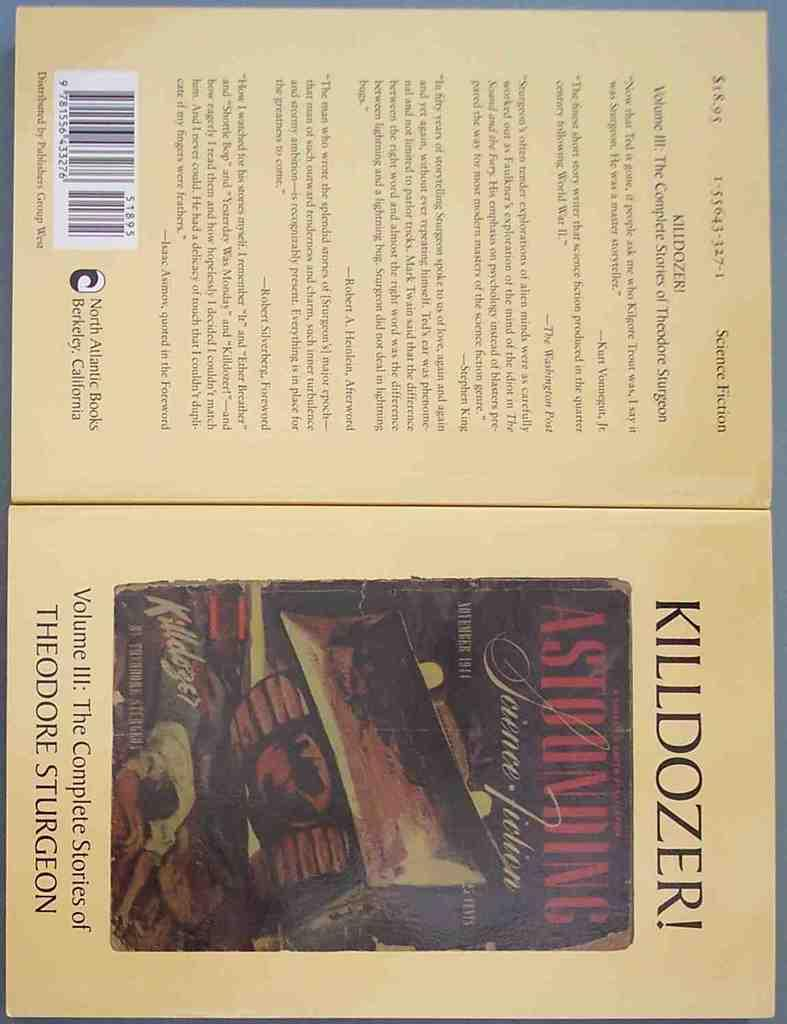<image>
Present a compact description of the photo's key features. A book jacket that shows front and back, titled Killdozer! 